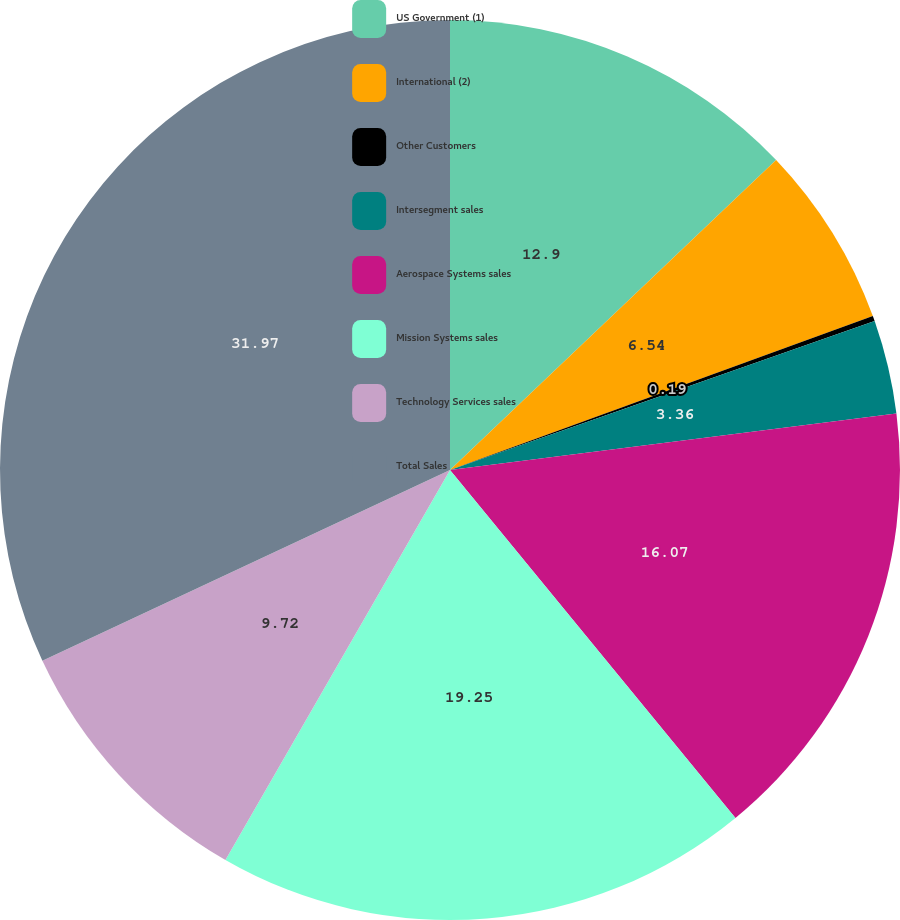Convert chart to OTSL. <chart><loc_0><loc_0><loc_500><loc_500><pie_chart><fcel>US Government (1)<fcel>International (2)<fcel>Other Customers<fcel>Intersegment sales<fcel>Aerospace Systems sales<fcel>Mission Systems sales<fcel>Technology Services sales<fcel>Total Sales<nl><fcel>12.9%<fcel>6.54%<fcel>0.19%<fcel>3.36%<fcel>16.07%<fcel>19.25%<fcel>9.72%<fcel>31.96%<nl></chart> 